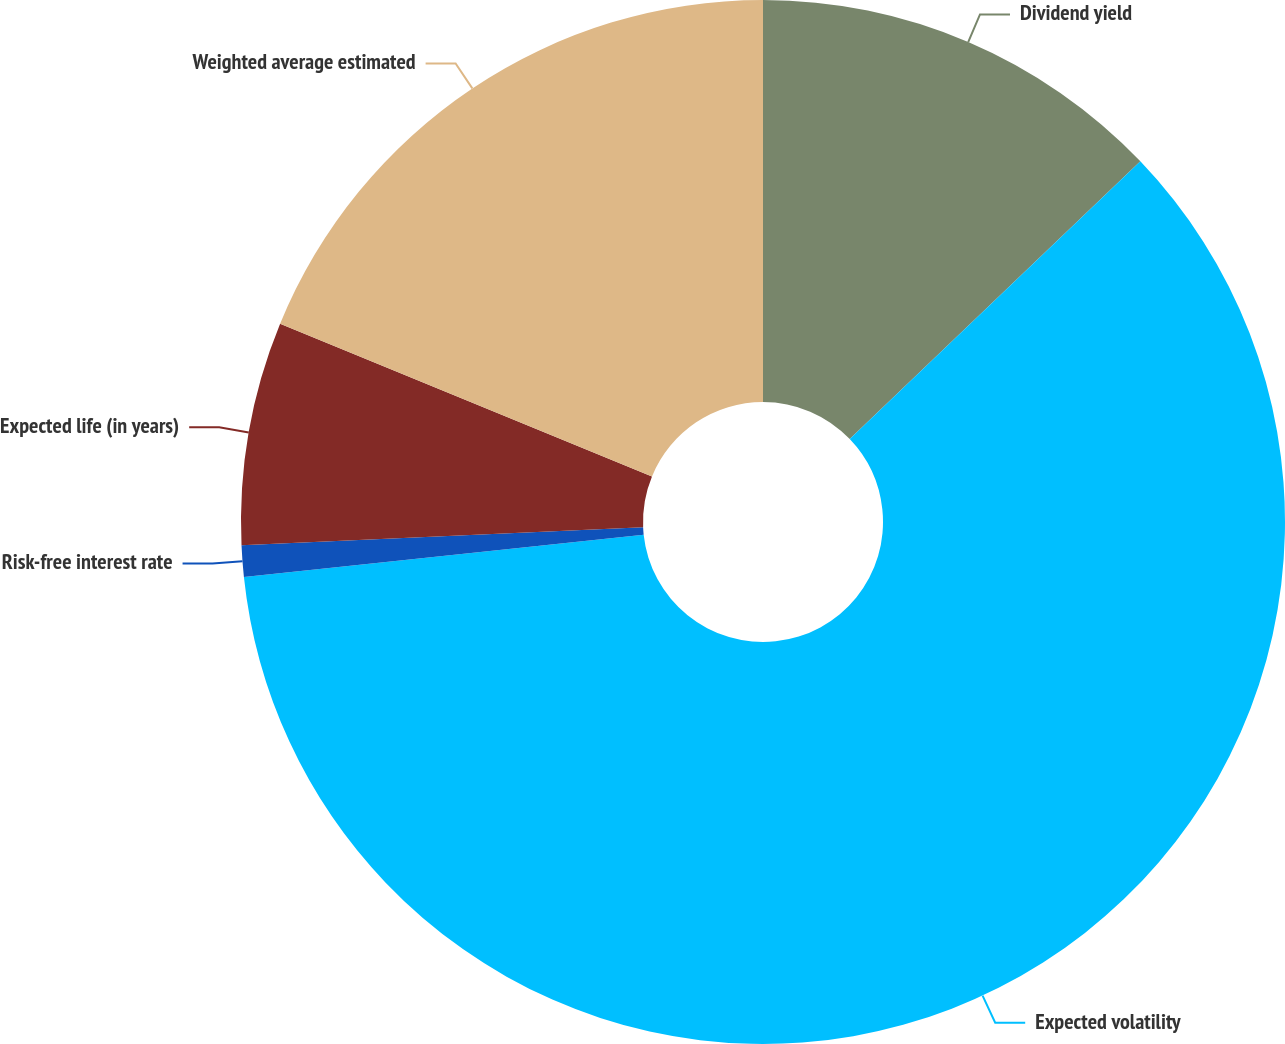Convert chart. <chart><loc_0><loc_0><loc_500><loc_500><pie_chart><fcel>Dividend yield<fcel>Expected volatility<fcel>Risk-free interest rate<fcel>Expected life (in years)<fcel>Weighted average estimated<nl><fcel>12.86%<fcel>60.46%<fcel>0.97%<fcel>6.91%<fcel>18.8%<nl></chart> 